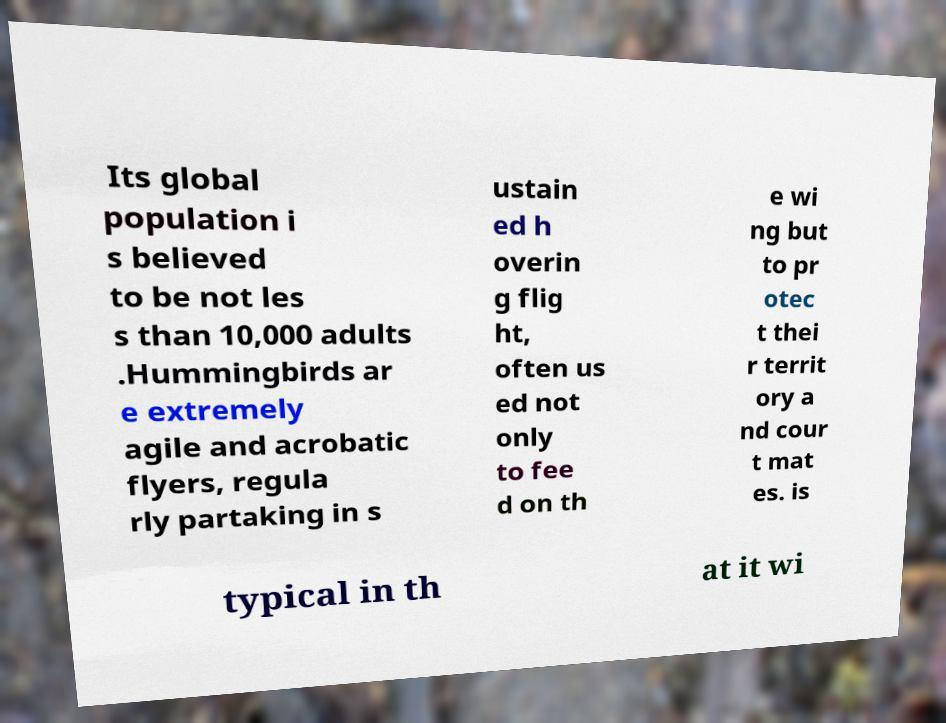Please read and relay the text visible in this image. What does it say? Its global population i s believed to be not les s than 10,000 adults .Hummingbirds ar e extremely agile and acrobatic flyers, regula rly partaking in s ustain ed h overin g flig ht, often us ed not only to fee d on th e wi ng but to pr otec t thei r territ ory a nd cour t mat es. is typical in th at it wi 